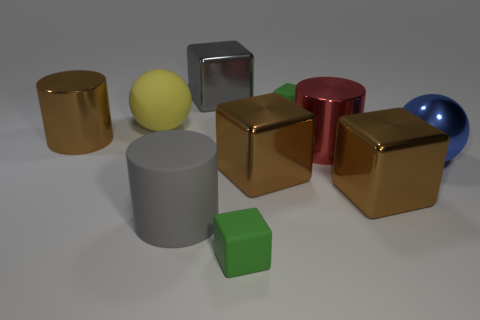Subtract all gray blocks. How many blocks are left? 4 Subtract all gray blocks. How many blocks are left? 4 Subtract 1 blocks. How many blocks are left? 4 Subtract all red blocks. Subtract all brown spheres. How many blocks are left? 5 Subtract all cylinders. How many objects are left? 7 Subtract all balls. Subtract all big matte balls. How many objects are left? 7 Add 6 big gray things. How many big gray things are left? 8 Add 3 big metallic cubes. How many big metallic cubes exist? 6 Subtract 1 red cylinders. How many objects are left? 9 